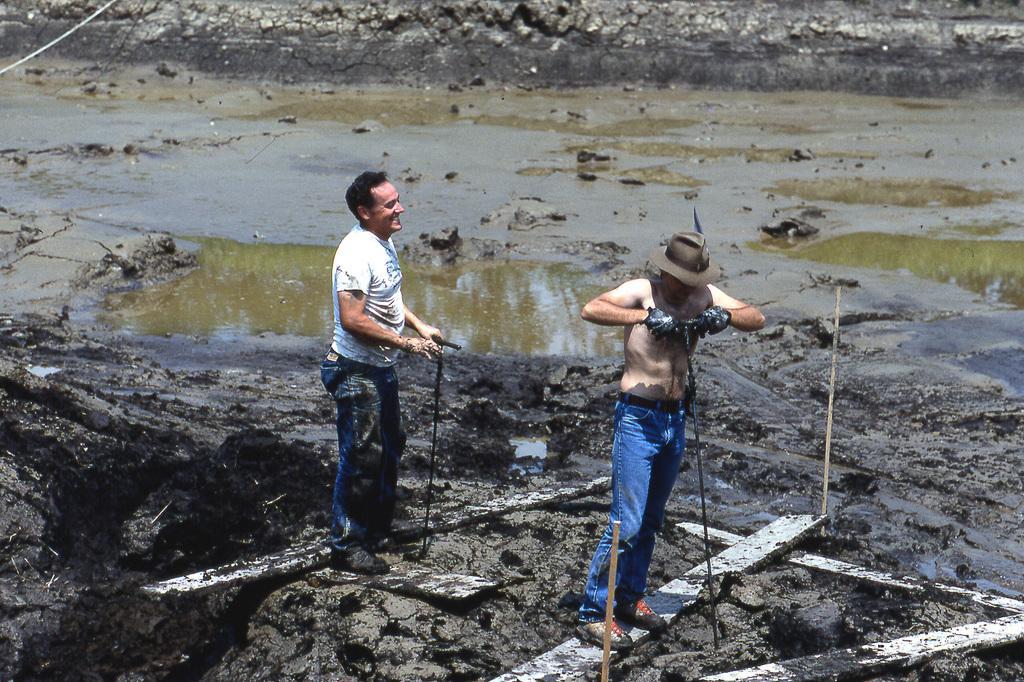In one or two sentences, can you explain what this image depicts? In the foreground of this image, there are two men standing on a wooden plank and holding a object. Around them, there is water staged and also the muddy land. 